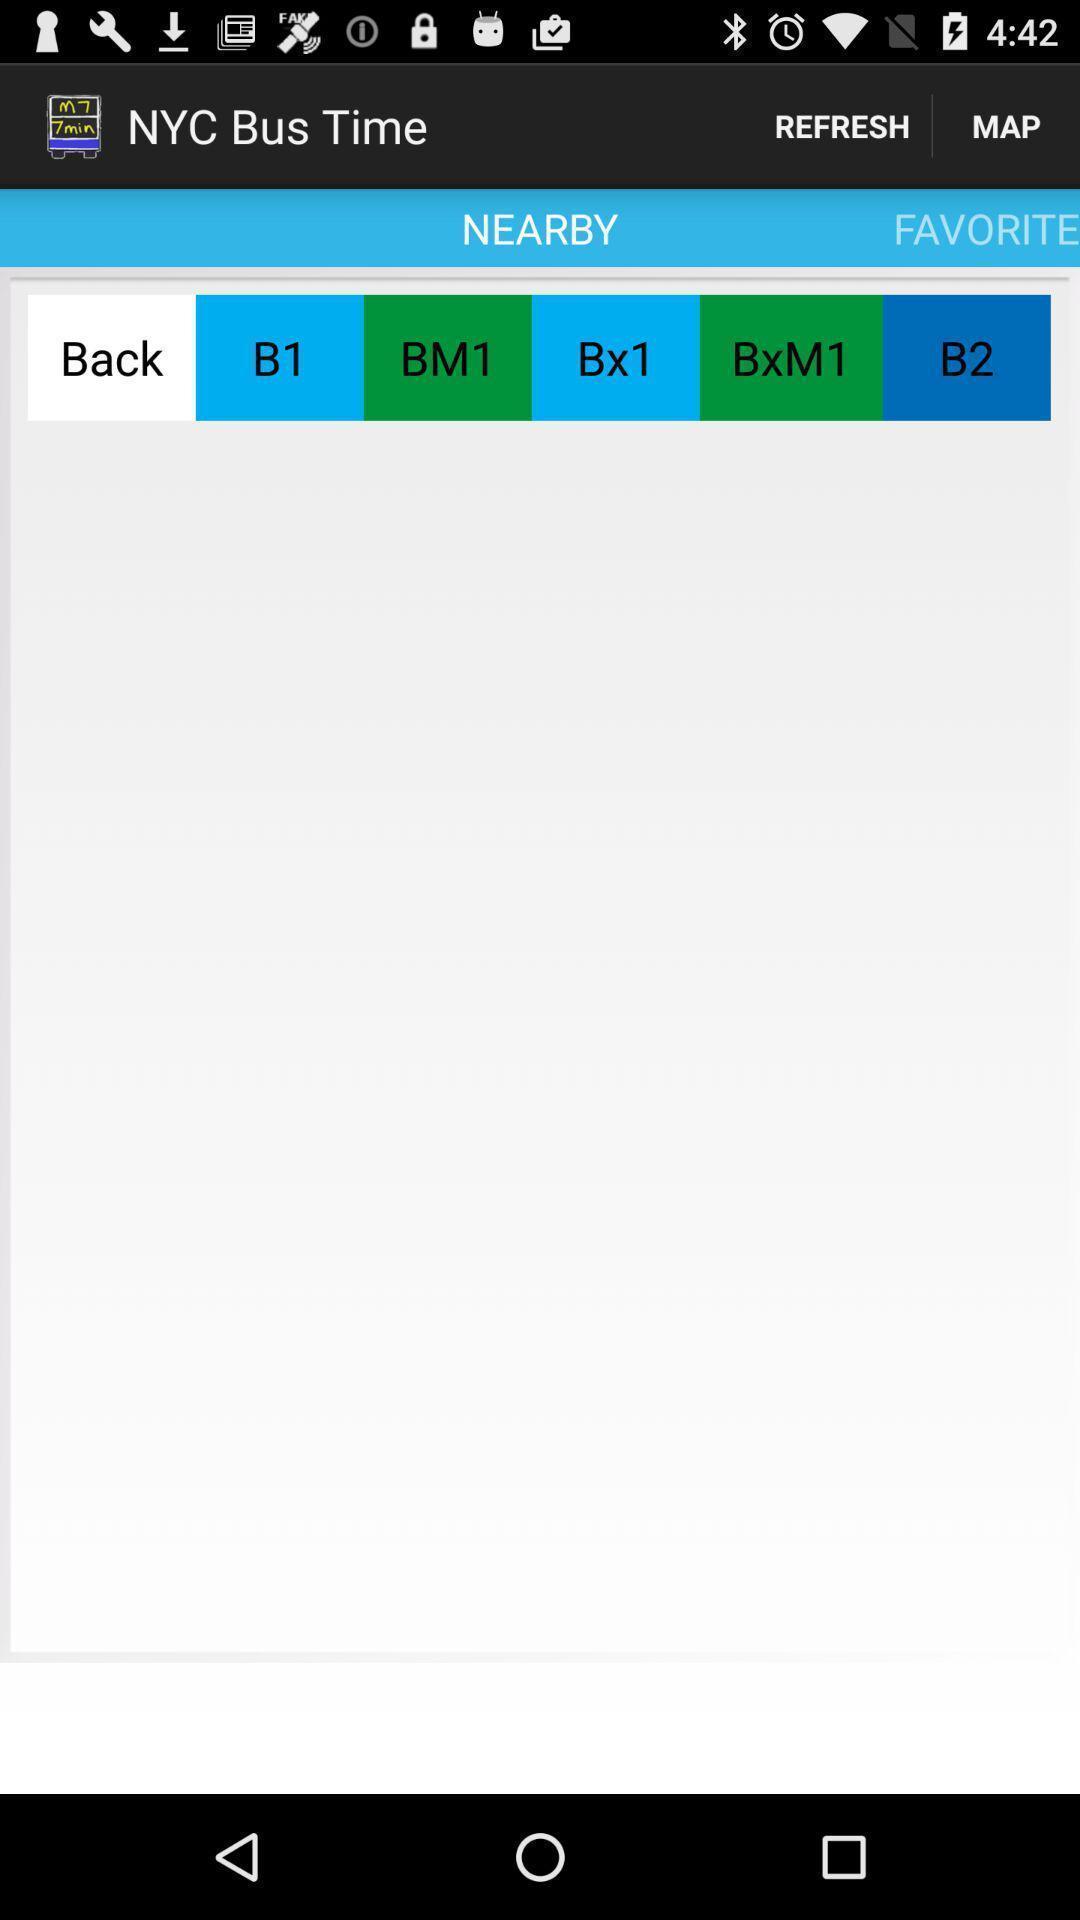Please provide a description for this image. Screen shows a nearby station in a bus tracker app. 